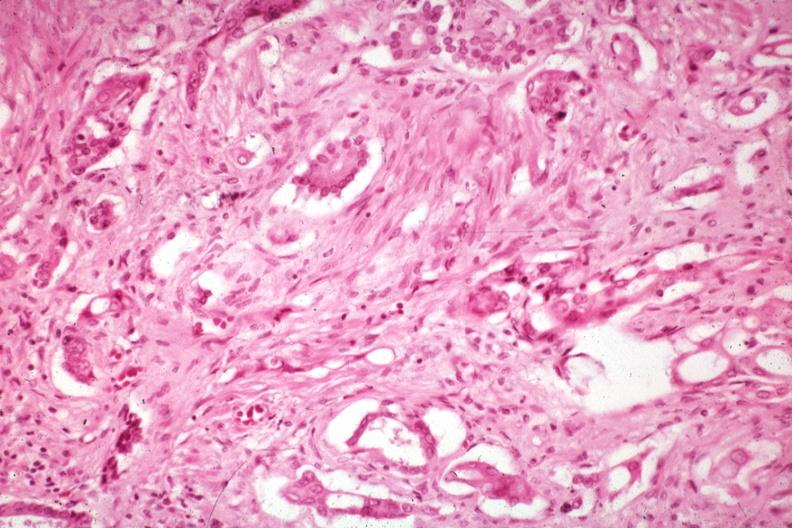what are prominent in the stroma?
Answer the question using a single word or phrase. Anaplastic carcinoma with desmoplasia large myofibroblastic cell 